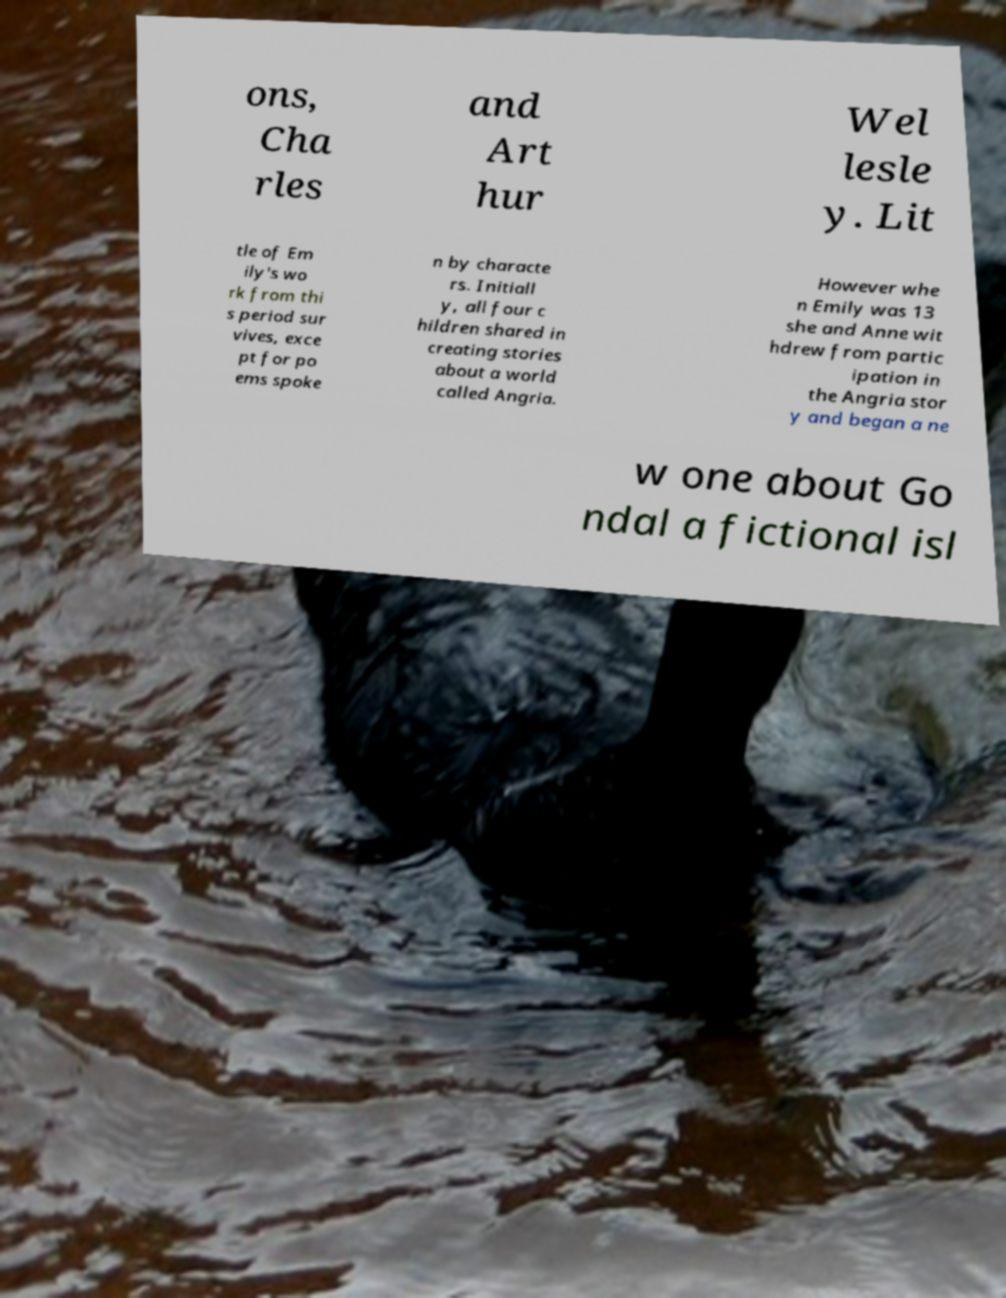Please read and relay the text visible in this image. What does it say? ons, Cha rles and Art hur Wel lesle y. Lit tle of Em ily's wo rk from thi s period sur vives, exce pt for po ems spoke n by characte rs. Initiall y, all four c hildren shared in creating stories about a world called Angria. However whe n Emily was 13 she and Anne wit hdrew from partic ipation in the Angria stor y and began a ne w one about Go ndal a fictional isl 